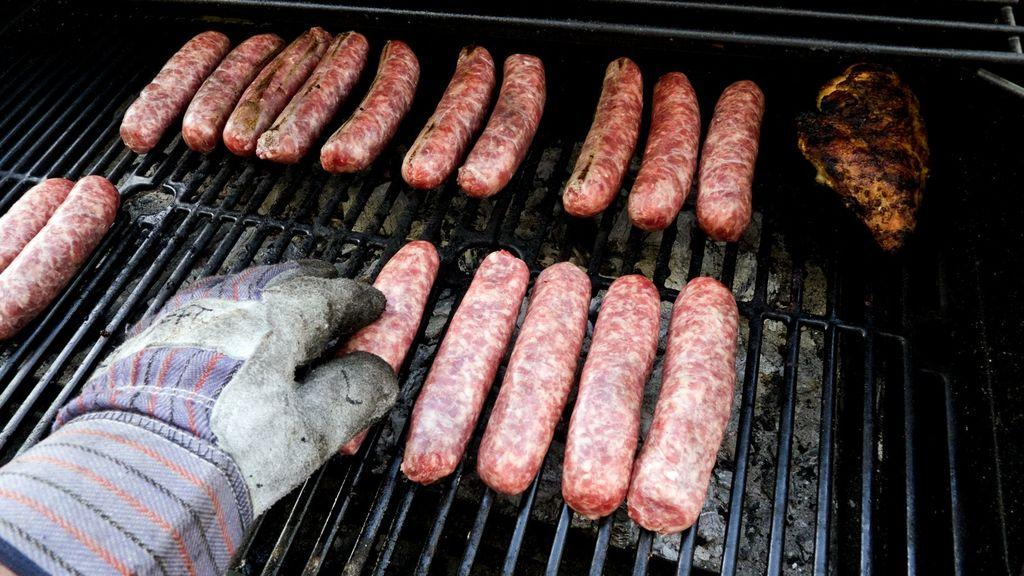What type of food can be seen in the image? There are pieces of sausages in the image. Where are the sausages located? The sausages are on a grill stand. Can you describe any other elements in the image? There is a person's hand with a glove in the image. How long does it take for the sausages to rest in the image? The concept of "rest" is not applicable to sausages in the image, as they are on a grill stand and not being prepared for consumption. 